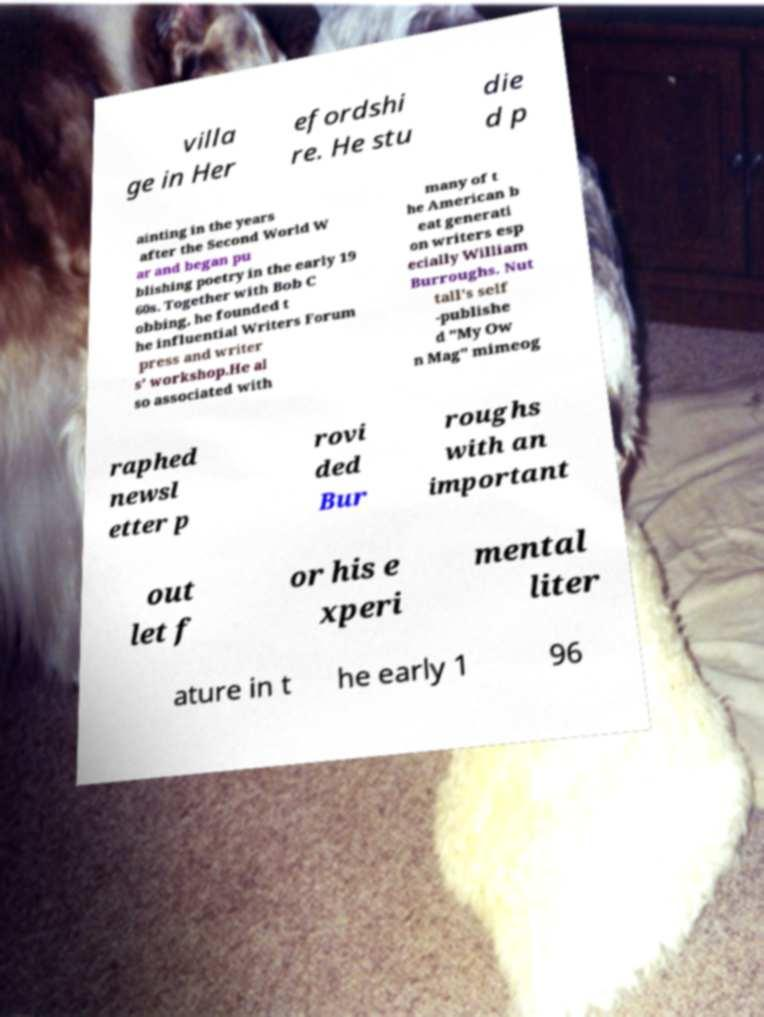Please identify and transcribe the text found in this image. villa ge in Her efordshi re. He stu die d p ainting in the years after the Second World W ar and began pu blishing poetry in the early 19 60s. Together with Bob C obbing, he founded t he influential Writers Forum press and writer s' workshop.He al so associated with many of t he American b eat generati on writers esp ecially William Burroughs. Nut tall's self -publishe d "My Ow n Mag" mimeog raphed newsl etter p rovi ded Bur roughs with an important out let f or his e xperi mental liter ature in t he early 1 96 